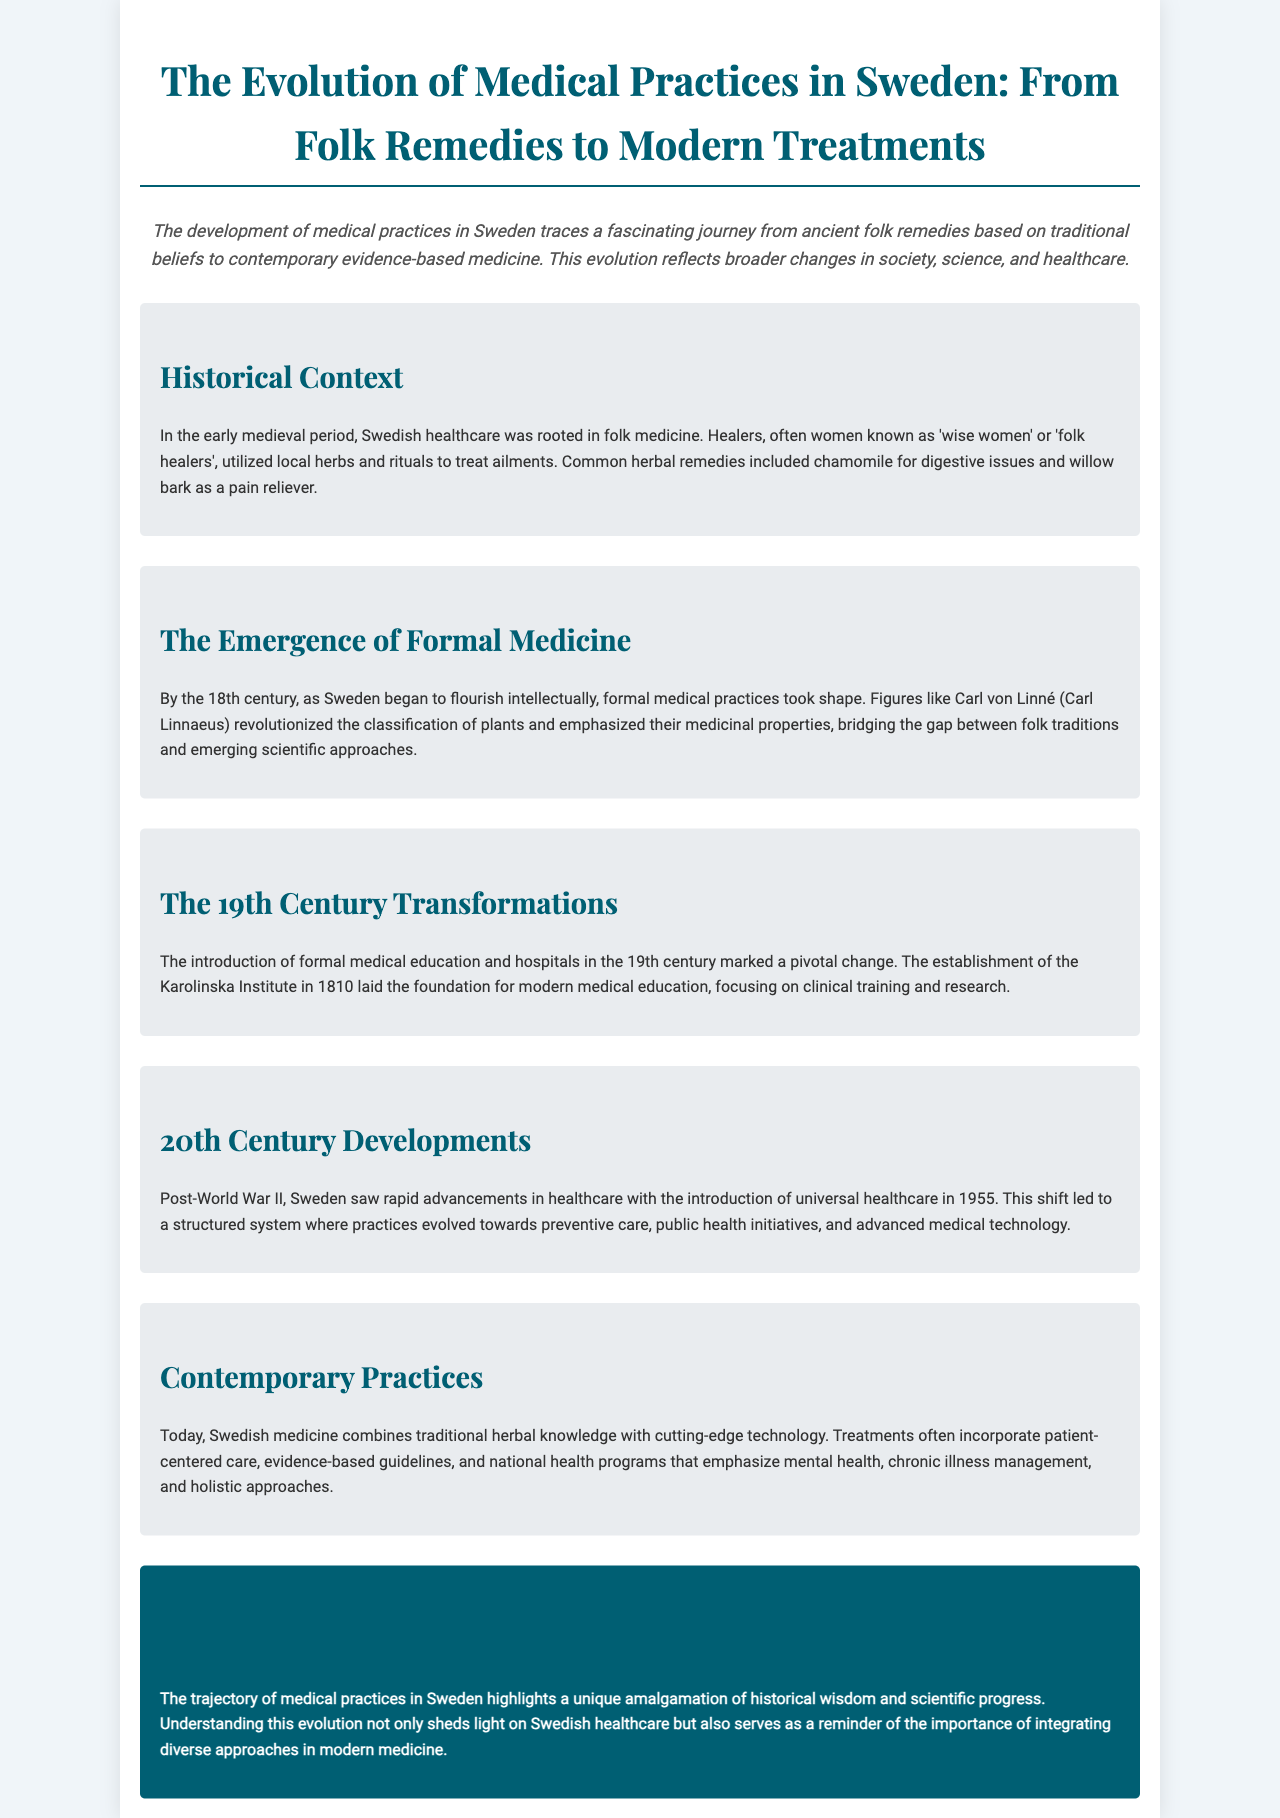What was the role of 'wise women' in early Swedish healthcare? 'Wise women' or 'folk healers' utilized local herbs and rituals to treat ailments.
Answer: Folk healers Who revolutionized the classification of plants in the 18th century? Carl von Linné (Carl Linnaeus) is noted for his work in plant classification and medicinal properties.
Answer: Carl von Linné When was the Karolinska Institute established? The Karolinska Institute was established in 1810, marking a pivotal change in medical education.
Answer: 1810 What significant healthcare shift occurred in Sweden in 1955? The shift towards universal healthcare occurred, creating a structured system focused on preventive care.
Answer: Universal healthcare What does contemporary Swedish medicine emphasize? Contemporary practices emphasize patient-centered care and evidence-based guidelines.
Answer: Patient-centered care In what century did formal medical practices begin to take shape in Sweden? The emergence of formal medical practices began in the 18th century.
Answer: 18th century What type of healthcare system developed in Sweden post-World War II? A structured healthcare system focused on preventive care and public health initiatives developed.
Answer: Structured healthcare system What type of medical practices combines traditional knowledge with technology today? Contemporary practices incorporate both traditional herbal knowledge and advanced medical technology.
Answer: Contemporary practices 